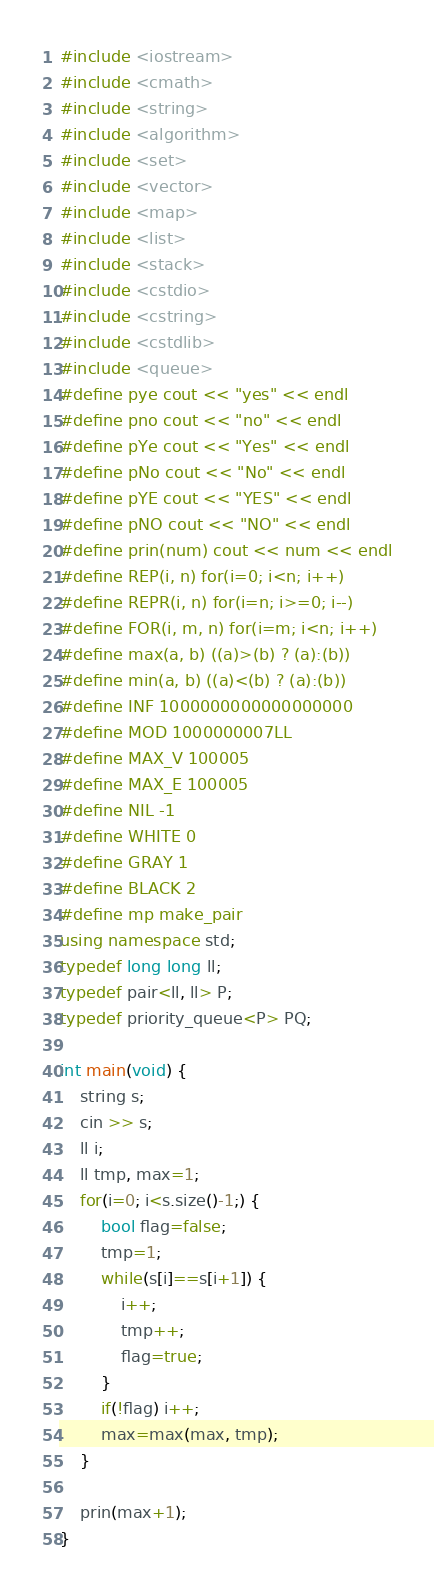<code> <loc_0><loc_0><loc_500><loc_500><_C++_>#include <iostream>
#include <cmath>
#include <string>
#include <algorithm>
#include <set>
#include <vector>
#include <map>
#include <list>
#include <stack>
#include <cstdio>
#include <cstring>
#include <cstdlib>
#include <queue>
#define pye cout << "yes" << endl
#define pno cout << "no" << endl
#define pYe cout << "Yes" << endl
#define pNo cout << "No" << endl
#define pYE cout << "YES" << endl
#define pNO cout << "NO" << endl
#define prin(num) cout << num << endl
#define REP(i, n) for(i=0; i<n; i++)
#define REPR(i, n) for(i=n; i>=0; i--)
#define FOR(i, m, n) for(i=m; i<n; i++)
#define max(a, b) ((a)>(b) ? (a):(b))
#define min(a, b) ((a)<(b) ? (a):(b))
#define INF 1000000000000000000
#define MOD 1000000007LL
#define MAX_V 100005
#define MAX_E 100005
#define NIL -1
#define WHITE 0
#define GRAY 1
#define BLACK 2
#define mp make_pair
using namespace std;
typedef long long ll;
typedef pair<ll, ll> P;
typedef priority_queue<P> PQ;

int main(void) {
    string s;
    cin >> s;
    ll i;
    ll tmp, max=1;
    for(i=0; i<s.size()-1;) {
        bool flag=false;
        tmp=1;
        while(s[i]==s[i+1]) {
            i++;
            tmp++;
            flag=true;
        }
        if(!flag) i++;
        max=max(max, tmp);
    }
    
    prin(max+1);
}</code> 